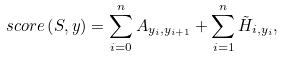<formula> <loc_0><loc_0><loc_500><loc_500>s c o r e \left ( S , y \right ) = \sum _ { i = 0 } ^ { n } A _ { y _ { i } , y _ { i + 1 } } + \sum _ { i = 1 } ^ { n } \tilde { H } _ { i , y _ { i } } ,</formula> 